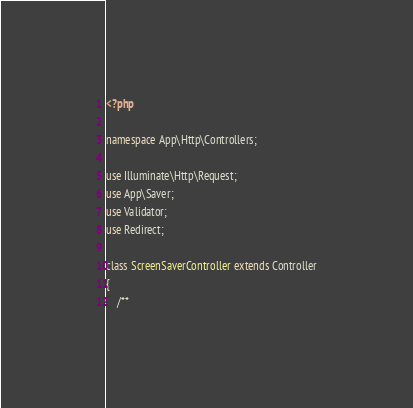Convert code to text. <code><loc_0><loc_0><loc_500><loc_500><_PHP_><?php

namespace App\Http\Controllers;

use Illuminate\Http\Request;
use App\Saver;
use Validator;
use Redirect;

class ScreenSaverController extends Controller
{
    /**</code> 